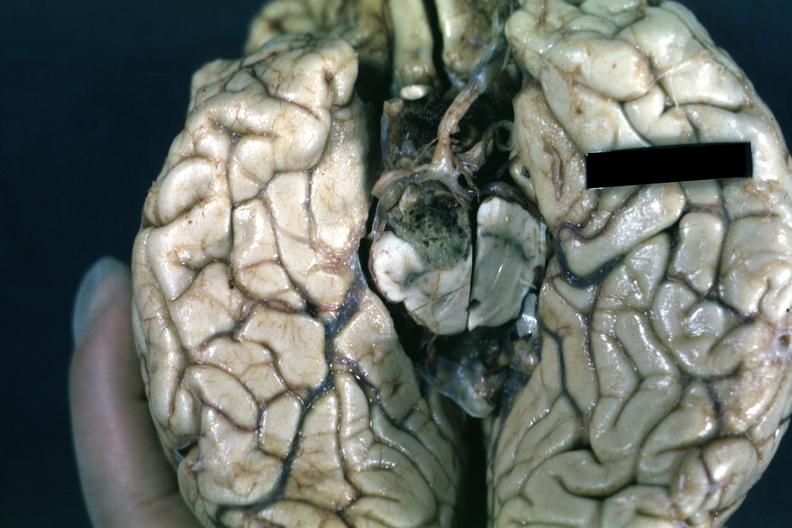s chromophobe adenoma present?
Answer the question using a single word or phrase. Yes 